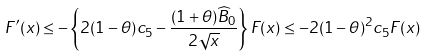Convert formula to latex. <formula><loc_0><loc_0><loc_500><loc_500>F ^ { \prime } ( x ) \leq - \left \{ 2 ( 1 - \theta ) c _ { 5 } - \frac { ( 1 + \theta ) \widehat { B } _ { 0 } } { 2 \sqrt { x } } \right \} F ( x ) \leq - 2 ( 1 - \theta ) ^ { 2 } c _ { 5 } F ( x )</formula> 